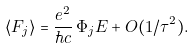Convert formula to latex. <formula><loc_0><loc_0><loc_500><loc_500>\langle F _ { j } \rangle = \frac { e ^ { 2 } } { \hbar { c } } \, \Phi _ { j } E + O ( 1 / \tau ^ { 2 } ) .</formula> 